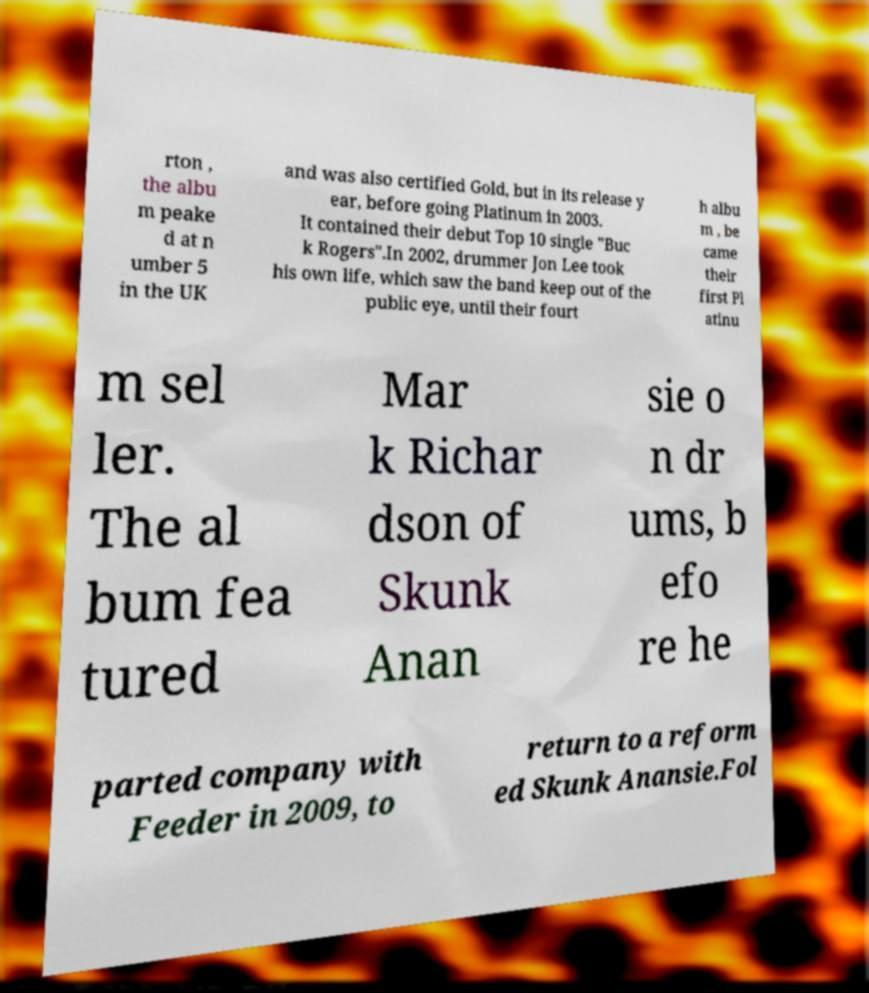Please identify and transcribe the text found in this image. rton , the albu m peake d at n umber 5 in the UK and was also certified Gold, but in its release y ear, before going Platinum in 2003. It contained their debut Top 10 single "Buc k Rogers".In 2002, drummer Jon Lee took his own life, which saw the band keep out of the public eye, until their fourt h albu m , be came their first Pl atinu m sel ler. The al bum fea tured Mar k Richar dson of Skunk Anan sie o n dr ums, b efo re he parted company with Feeder in 2009, to return to a reform ed Skunk Anansie.Fol 